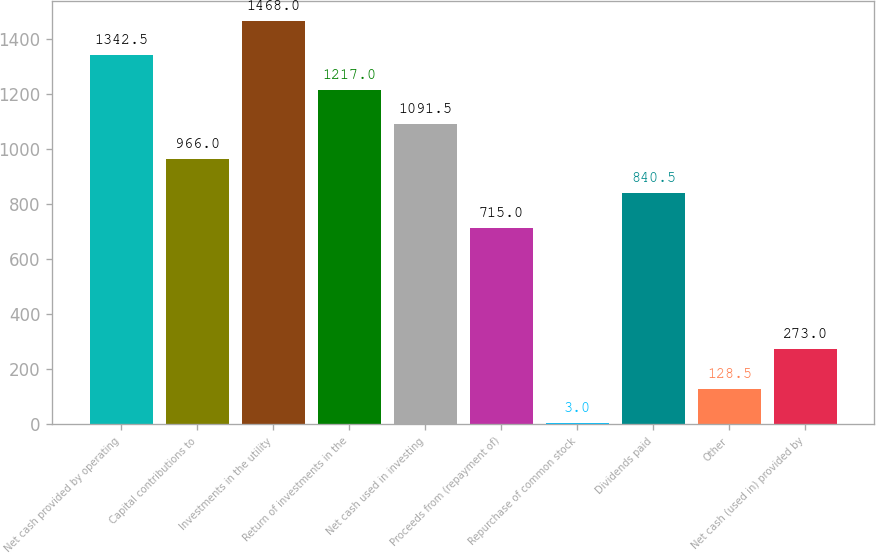<chart> <loc_0><loc_0><loc_500><loc_500><bar_chart><fcel>Net cash provided by operating<fcel>Capital contributions to<fcel>Investments in the utility<fcel>Return of investments in the<fcel>Net cash used in investing<fcel>Proceeds from (repayment of)<fcel>Repurchase of common stock<fcel>Dividends paid<fcel>Other<fcel>Net cash (used in) provided by<nl><fcel>1342.5<fcel>966<fcel>1468<fcel>1217<fcel>1091.5<fcel>715<fcel>3<fcel>840.5<fcel>128.5<fcel>273<nl></chart> 